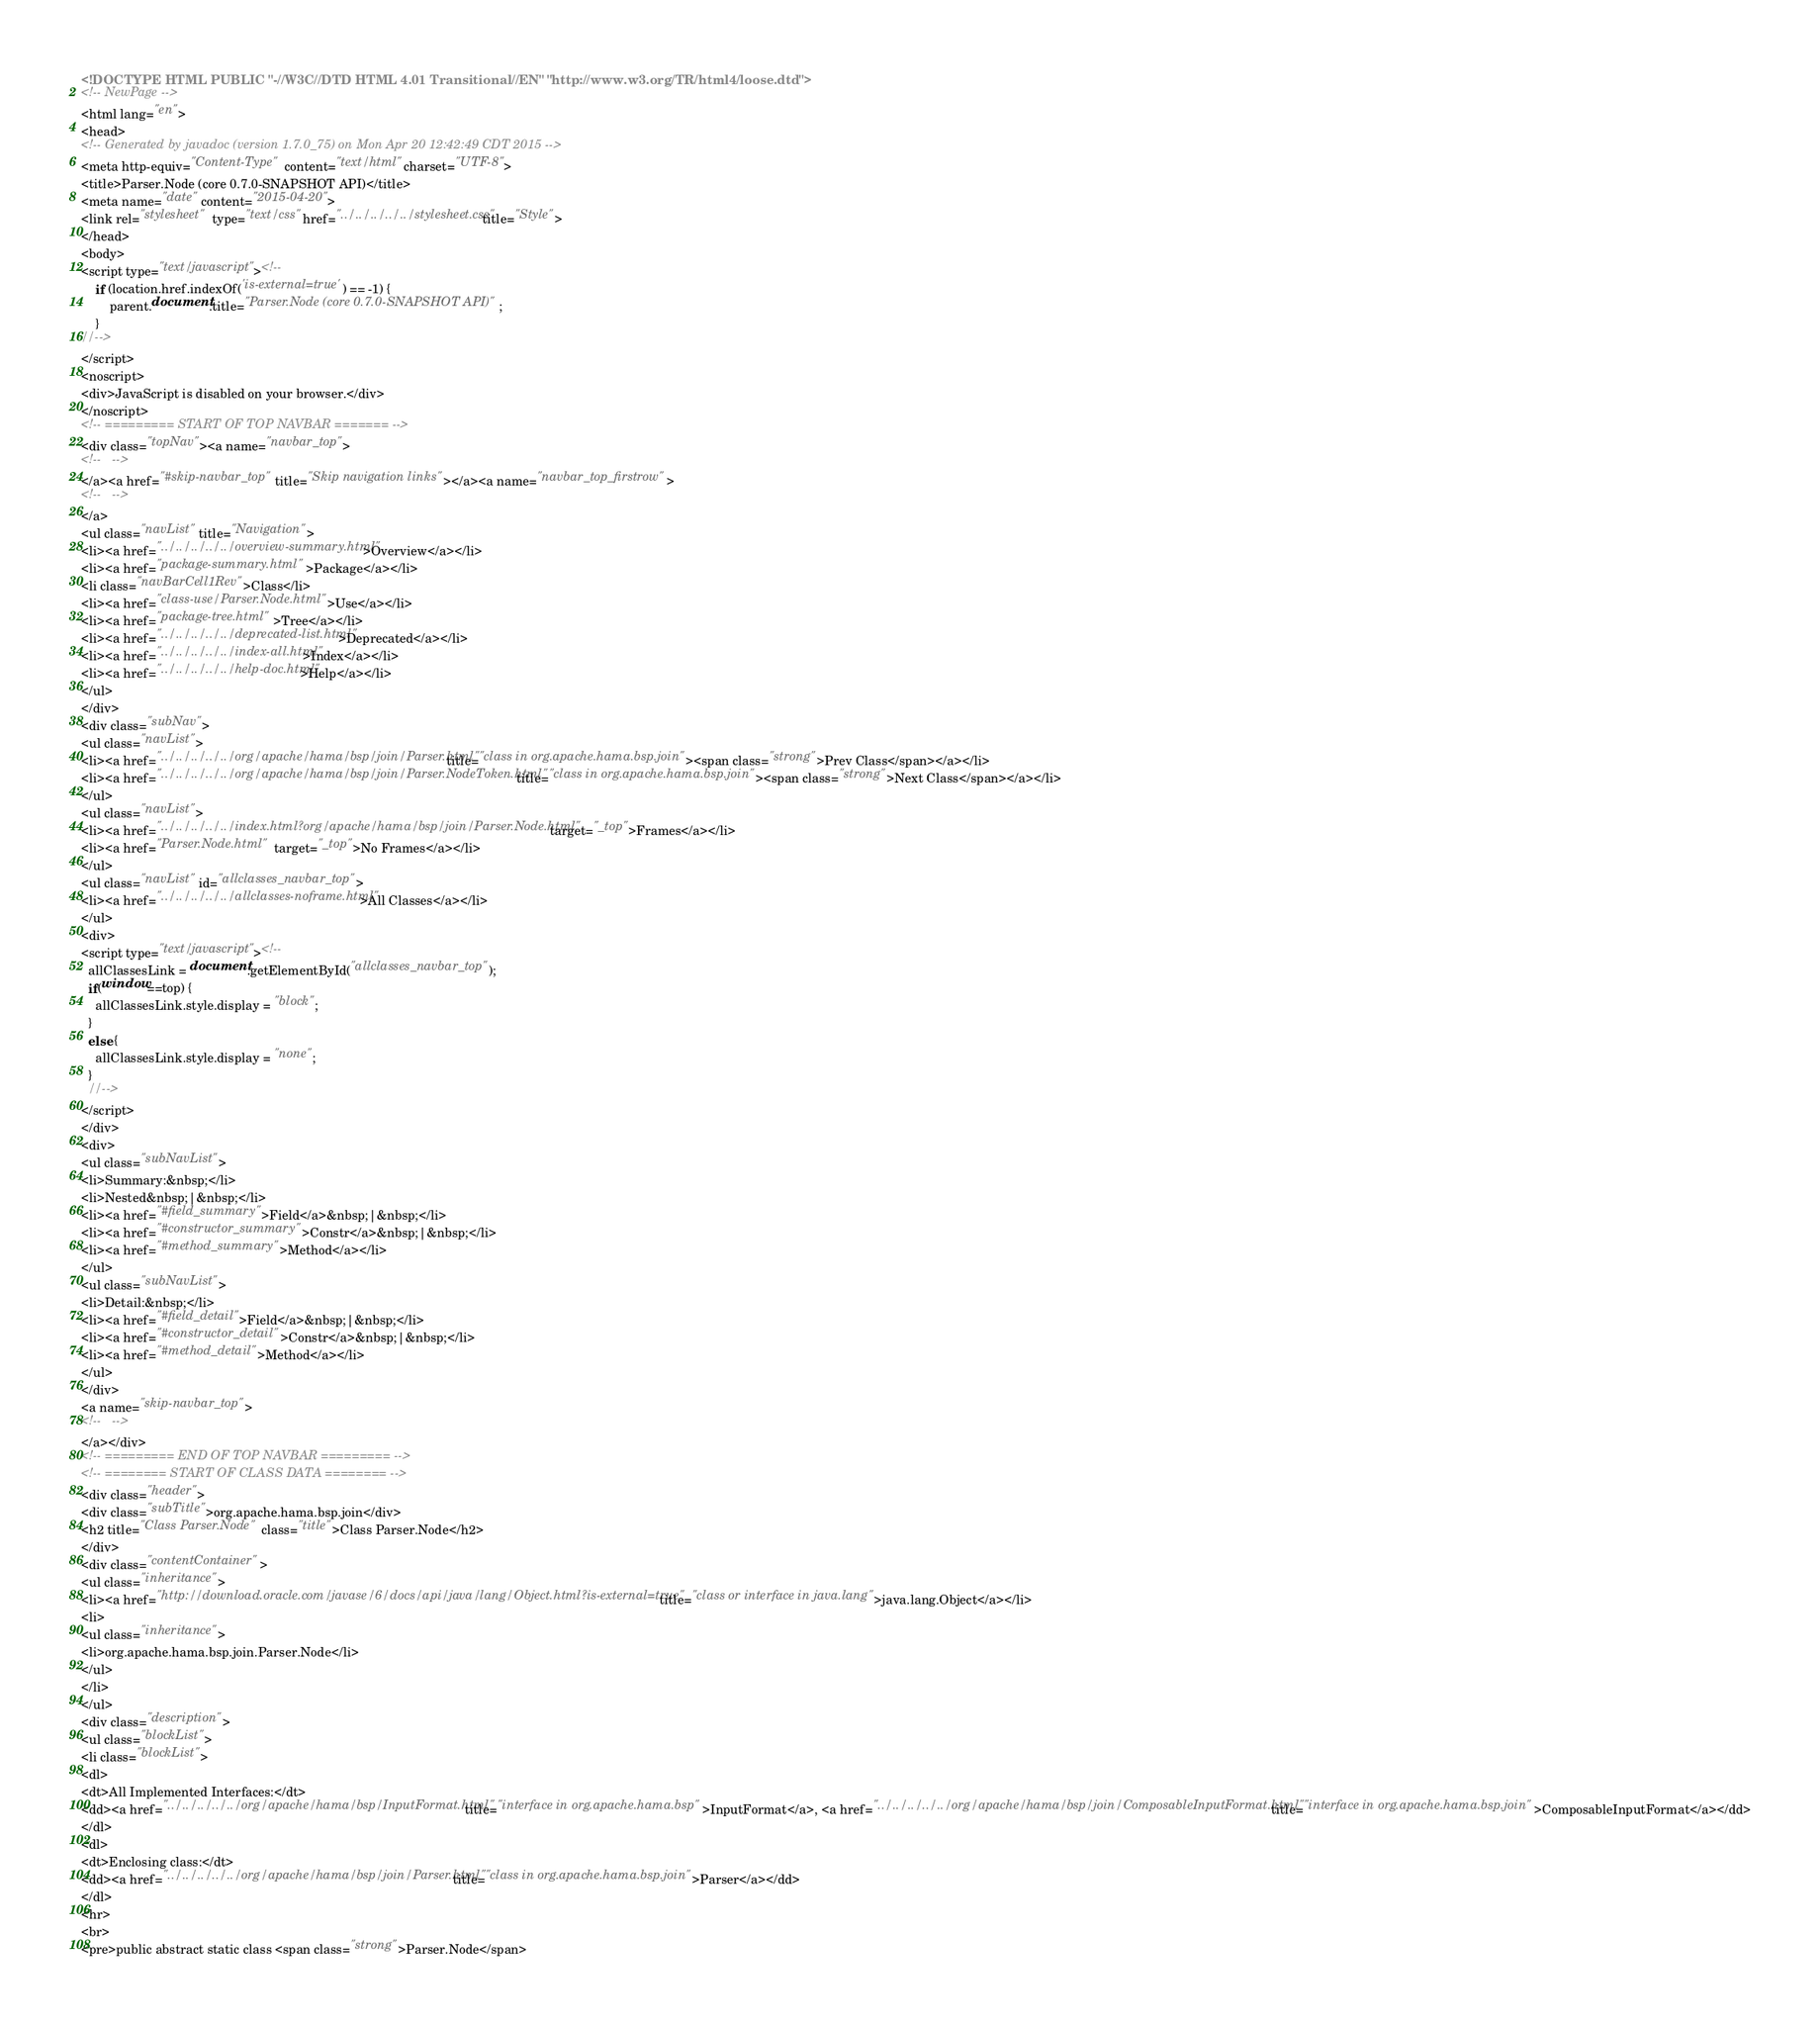<code> <loc_0><loc_0><loc_500><loc_500><_HTML_><!DOCTYPE HTML PUBLIC "-//W3C//DTD HTML 4.01 Transitional//EN" "http://www.w3.org/TR/html4/loose.dtd">
<!-- NewPage -->
<html lang="en">
<head>
<!-- Generated by javadoc (version 1.7.0_75) on Mon Apr 20 12:42:49 CDT 2015 -->
<meta http-equiv="Content-Type" content="text/html" charset="UTF-8">
<title>Parser.Node (core 0.7.0-SNAPSHOT API)</title>
<meta name="date" content="2015-04-20">
<link rel="stylesheet" type="text/css" href="../../../../../stylesheet.css" title="Style">
</head>
<body>
<script type="text/javascript"><!--
    if (location.href.indexOf('is-external=true') == -1) {
        parent.document.title="Parser.Node (core 0.7.0-SNAPSHOT API)";
    }
//-->
</script>
<noscript>
<div>JavaScript is disabled on your browser.</div>
</noscript>
<!-- ========= START OF TOP NAVBAR ======= -->
<div class="topNav"><a name="navbar_top">
<!--   -->
</a><a href="#skip-navbar_top" title="Skip navigation links"></a><a name="navbar_top_firstrow">
<!--   -->
</a>
<ul class="navList" title="Navigation">
<li><a href="../../../../../overview-summary.html">Overview</a></li>
<li><a href="package-summary.html">Package</a></li>
<li class="navBarCell1Rev">Class</li>
<li><a href="class-use/Parser.Node.html">Use</a></li>
<li><a href="package-tree.html">Tree</a></li>
<li><a href="../../../../../deprecated-list.html">Deprecated</a></li>
<li><a href="../../../../../index-all.html">Index</a></li>
<li><a href="../../../../../help-doc.html">Help</a></li>
</ul>
</div>
<div class="subNav">
<ul class="navList">
<li><a href="../../../../../org/apache/hama/bsp/join/Parser.html" title="class in org.apache.hama.bsp.join"><span class="strong">Prev Class</span></a></li>
<li><a href="../../../../../org/apache/hama/bsp/join/Parser.NodeToken.html" title="class in org.apache.hama.bsp.join"><span class="strong">Next Class</span></a></li>
</ul>
<ul class="navList">
<li><a href="../../../../../index.html?org/apache/hama/bsp/join/Parser.Node.html" target="_top">Frames</a></li>
<li><a href="Parser.Node.html" target="_top">No Frames</a></li>
</ul>
<ul class="navList" id="allclasses_navbar_top">
<li><a href="../../../../../allclasses-noframe.html">All Classes</a></li>
</ul>
<div>
<script type="text/javascript"><!--
  allClassesLink = document.getElementById("allclasses_navbar_top");
  if(window==top) {
    allClassesLink.style.display = "block";
  }
  else {
    allClassesLink.style.display = "none";
  }
  //-->
</script>
</div>
<div>
<ul class="subNavList">
<li>Summary:&nbsp;</li>
<li>Nested&nbsp;|&nbsp;</li>
<li><a href="#field_summary">Field</a>&nbsp;|&nbsp;</li>
<li><a href="#constructor_summary">Constr</a>&nbsp;|&nbsp;</li>
<li><a href="#method_summary">Method</a></li>
</ul>
<ul class="subNavList">
<li>Detail:&nbsp;</li>
<li><a href="#field_detail">Field</a>&nbsp;|&nbsp;</li>
<li><a href="#constructor_detail">Constr</a>&nbsp;|&nbsp;</li>
<li><a href="#method_detail">Method</a></li>
</ul>
</div>
<a name="skip-navbar_top">
<!--   -->
</a></div>
<!-- ========= END OF TOP NAVBAR ========= -->
<!-- ======== START OF CLASS DATA ======== -->
<div class="header">
<div class="subTitle">org.apache.hama.bsp.join</div>
<h2 title="Class Parser.Node" class="title">Class Parser.Node</h2>
</div>
<div class="contentContainer">
<ul class="inheritance">
<li><a href="http://download.oracle.com/javase/6/docs/api/java/lang/Object.html?is-external=true" title="class or interface in java.lang">java.lang.Object</a></li>
<li>
<ul class="inheritance">
<li>org.apache.hama.bsp.join.Parser.Node</li>
</ul>
</li>
</ul>
<div class="description">
<ul class="blockList">
<li class="blockList">
<dl>
<dt>All Implemented Interfaces:</dt>
<dd><a href="../../../../../org/apache/hama/bsp/InputFormat.html" title="interface in org.apache.hama.bsp">InputFormat</a>, <a href="../../../../../org/apache/hama/bsp/join/ComposableInputFormat.html" title="interface in org.apache.hama.bsp.join">ComposableInputFormat</a></dd>
</dl>
<dl>
<dt>Enclosing class:</dt>
<dd><a href="../../../../../org/apache/hama/bsp/join/Parser.html" title="class in org.apache.hama.bsp.join">Parser</a></dd>
</dl>
<hr>
<br>
<pre>public abstract static class <span class="strong">Parser.Node</span></code> 